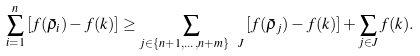<formula> <loc_0><loc_0><loc_500><loc_500>\sum _ { i = 1 } ^ { n } \left [ f ( \bar { \rho } _ { i } ) - f ( k ) \right ] \geq \sum _ { j \in \{ n + 1 , \dots , n + m \} \ J } \left [ f ( \bar { \rho } _ { j } ) - f ( k ) \right ] + \sum _ { j \in J } f ( k ) .</formula> 